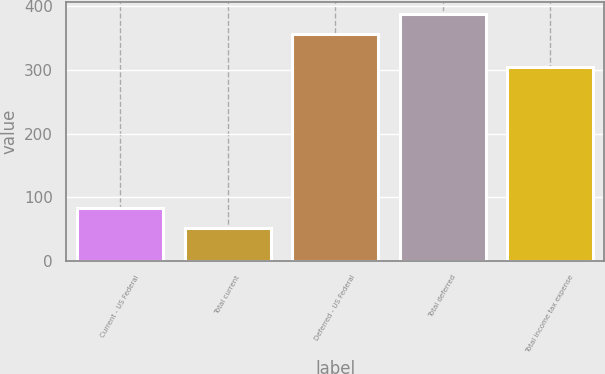<chart> <loc_0><loc_0><loc_500><loc_500><bar_chart><fcel>Current - US Federal<fcel>Total current<fcel>Deferred - US Federal<fcel>Total deferred<fcel>Total income tax expense<nl><fcel>82.5<fcel>52<fcel>357<fcel>387.5<fcel>305<nl></chart> 